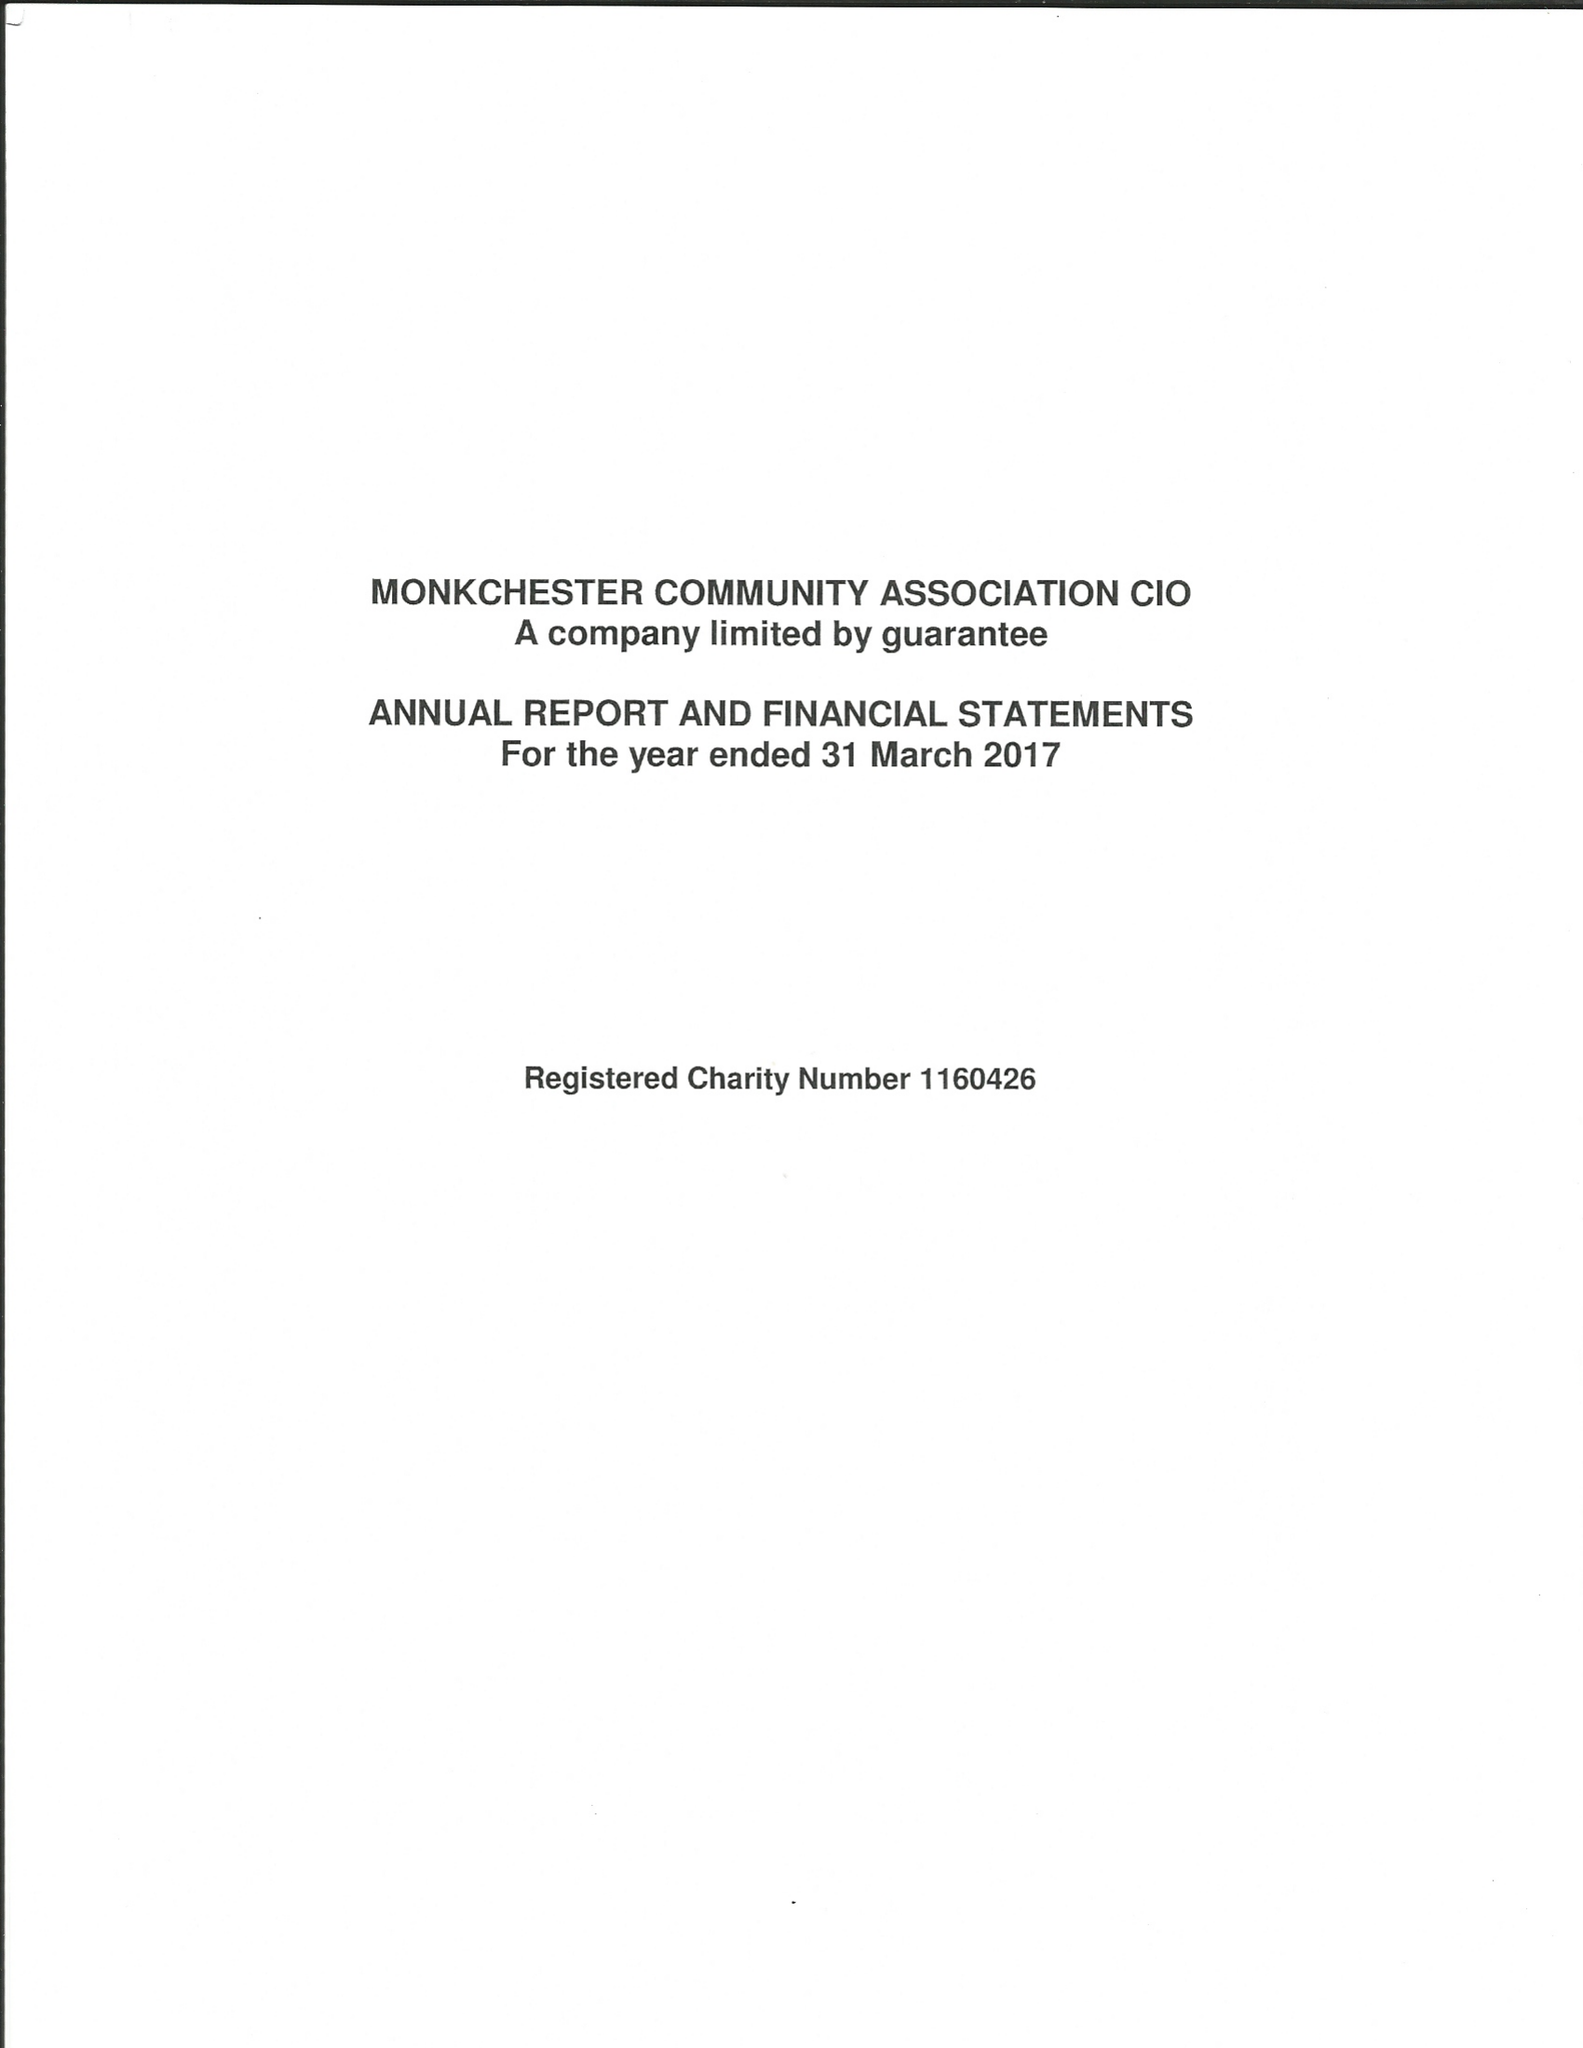What is the value for the charity_number?
Answer the question using a single word or phrase. 1160426 